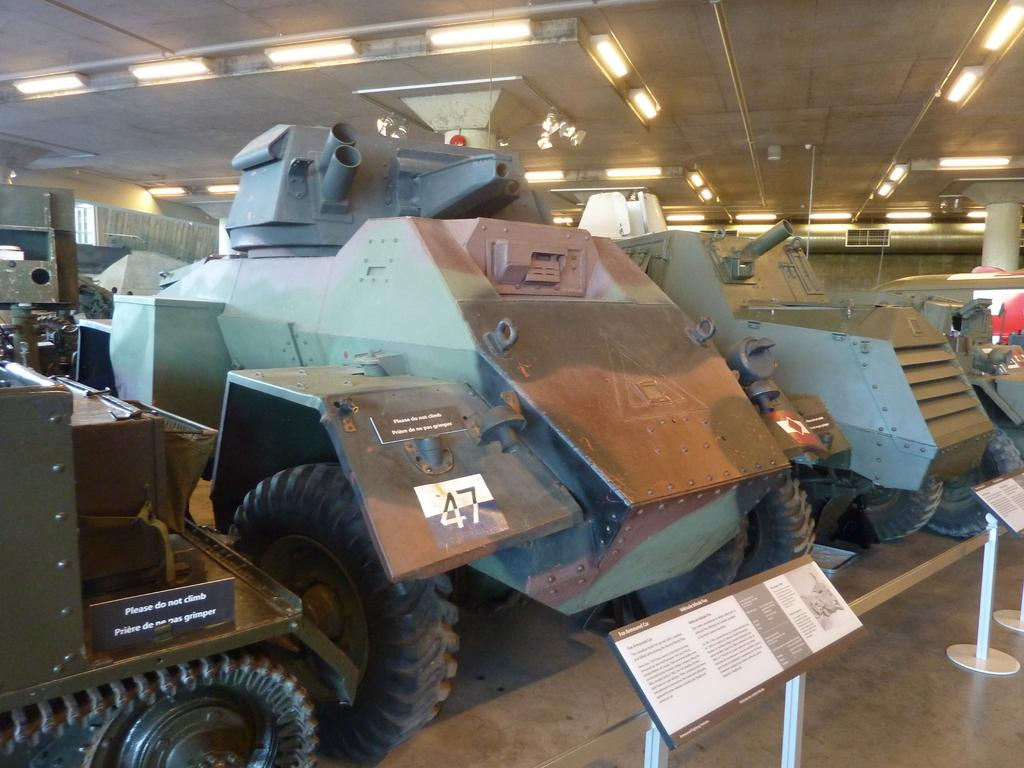What type of vehicles are present in the image? There are war tanks in the image. What can be seen in the bottom right corner of the image? There is a board in the bottom right of the image. What is visible on the ceiling in the image? There are lights on the ceiling, which is at the top of the image. What type of society is depicted in the image? The image does not depict a society; it features war tanks and other elements. What story is being told in the image? The image does not tell a story; it is a static representation of war tanks and other elements. 